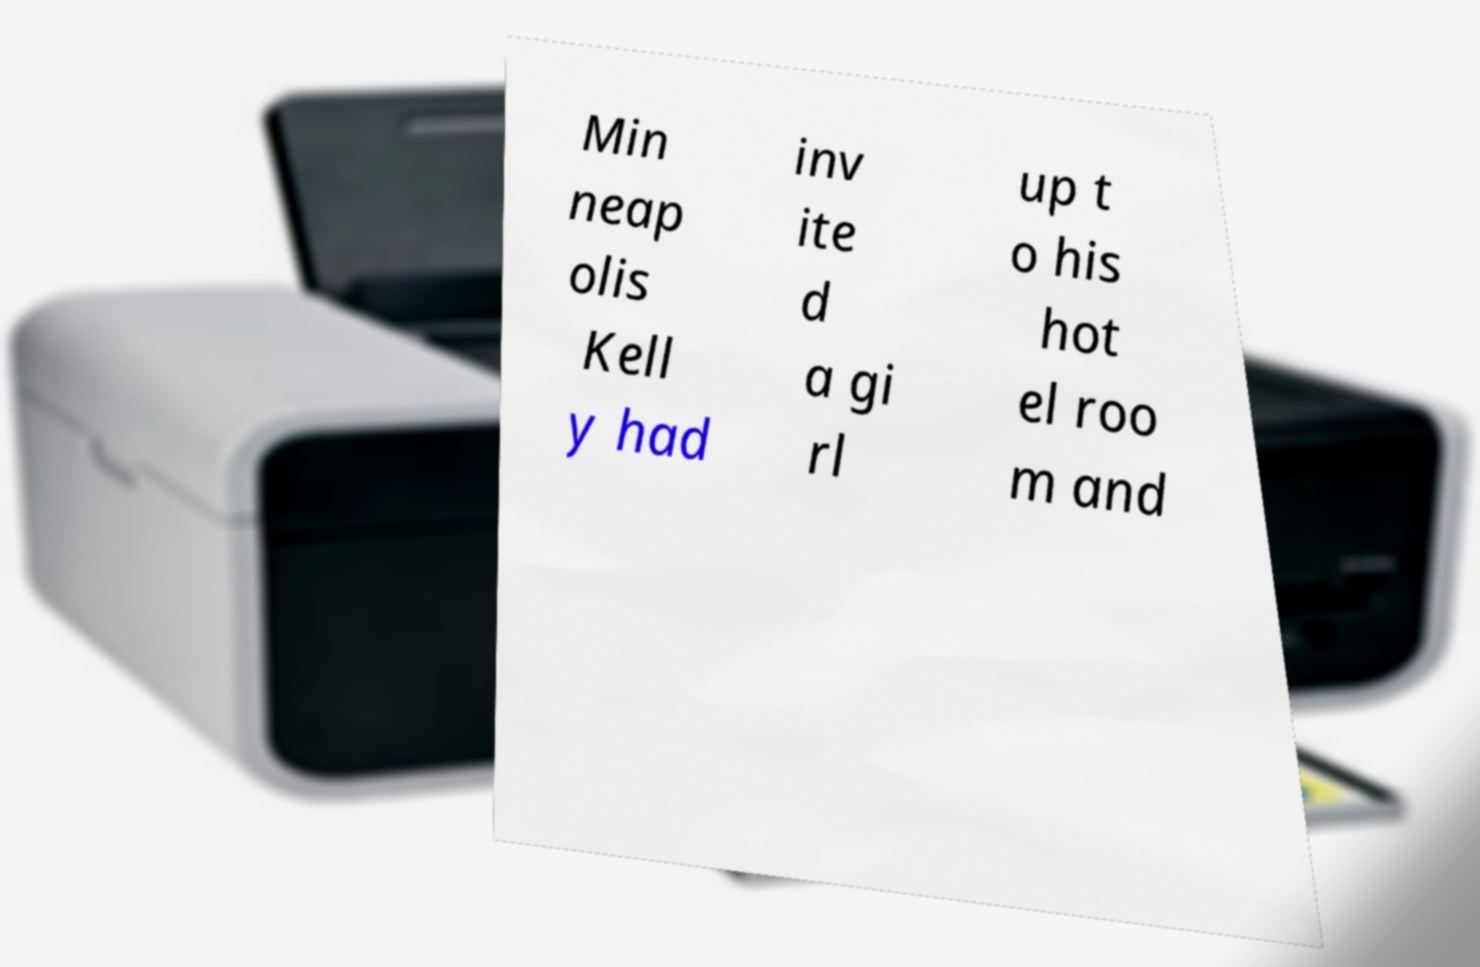Could you assist in decoding the text presented in this image and type it out clearly? Min neap olis Kell y had inv ite d a gi rl up t o his hot el roo m and 